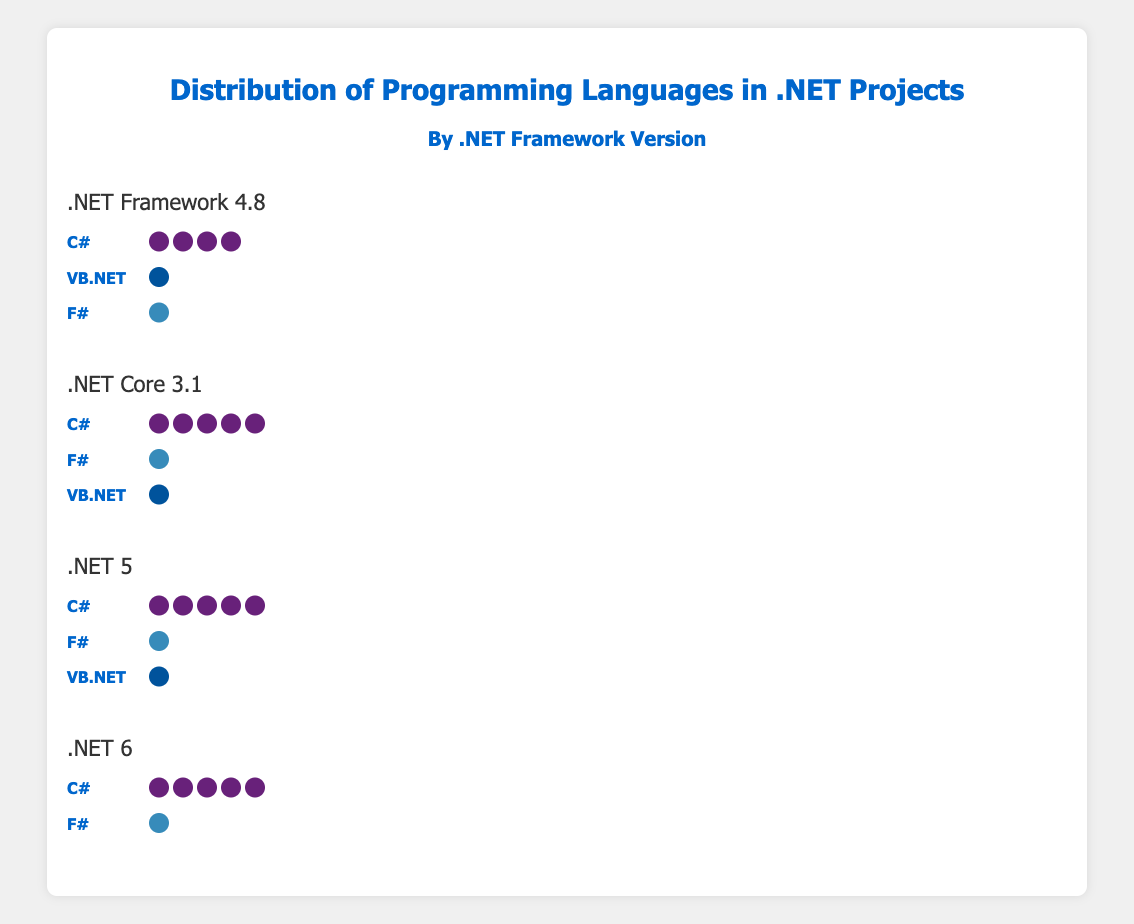Which programming language appears the most in the .NET Framework 4.8 projects? The Isotype Plot shows the distribution of programming languages in .NET projects. For .NET Framework 4.8, C# has the most icons visible, indicating the highest count.
Answer: C# Which framework version has the least number of VB.NET projects? To determine this, compare the counts of VB.NET across all framework versions. .NET 6 has zero VB.NET projects, the least among all versions.
Answer: .NET 6 How does the distribution of F# projects change from .NET Framework 4.8 to .NET 5? Calculate the difference in the number of F# projects between the two framework versions. The count for F# decreases from 5 in .NET Framework 4.8 to 4 in .NET 5.
Answer: Decreases by 1 Which framework version has the highest number of F# projects? Examine the counts of F# projects across all versions. .NET Core 3.1 has the highest count with 8 projects.
Answer: .NET Core 3.1 What is the total number of C# projects across all framework versions? Sum the counts of C# projects for each framework version: 80 (4.8) + 90 (3.1) + 95 (5) + 97 (6). The total is 362.
Answer: 362 Compare the number of projects using C# and VB.NET in .NET Core 3.1. The plot shows that C# has 90 projects and VB.NET has 2 projects in .NET Core 3.1. C# has significantly more projects than VB.NET.
Answer: C# > VB.NET Is F# used in all framework versions presented? Check each framework version for the presence of F# icons. F# is present in all the versions: .NET Framework 4.8, .NET Core 3.1, .NET 5, and .NET 6.
Answer: Yes What frameworks do not use VB.NET? Identify frameworks where no VB.NET icons are shown. .NET 6 does not use VB.NET.
Answer: .NET 6 What is the difference in the number of C# projects between .NET 5 and .NET Core 3.1? Subtract the count of C# projects in .NET Core 3.1 from those in .NET 5: 95 - 90 = 5.
Answer: 5 How does the number of F# projects in .NET 5 compare to .NET 6? Compare the counts: .NET 5 has 4 F# projects, while .NET 6 has 3. F# projects decrease from .NET 5 to .NET 6.
Answer: Decreases by 1 